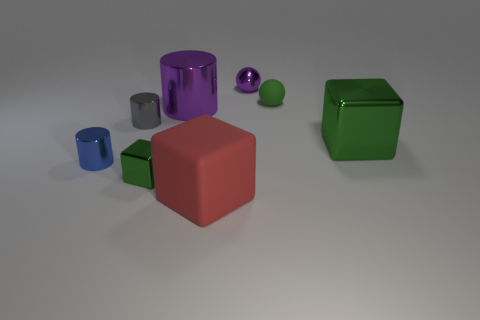There is a tiny ball that is to the right of the tiny metal sphere; what is its color?
Keep it short and to the point. Green. Is there another big matte thing of the same shape as the big green thing?
Give a very brief answer. Yes. How many brown things are either large cylinders or small shiny objects?
Your answer should be very brief. 0. Is there a metal thing that has the same size as the green matte ball?
Your answer should be very brief. Yes. How many green blocks are there?
Make the answer very short. 2. How many tiny objects are blue metallic cylinders or cylinders?
Offer a very short reply. 2. There is a large metallic thing behind the big metal thing that is right of the green thing that is behind the large purple metal thing; what is its color?
Ensure brevity in your answer.  Purple. What number of other objects are the same color as the tiny metal cube?
Your answer should be compact. 2. How many rubber objects are either big balls or small purple objects?
Make the answer very short. 0. Does the metallic block that is to the left of the purple sphere have the same color as the matte object behind the big green metallic thing?
Provide a succinct answer. Yes. 